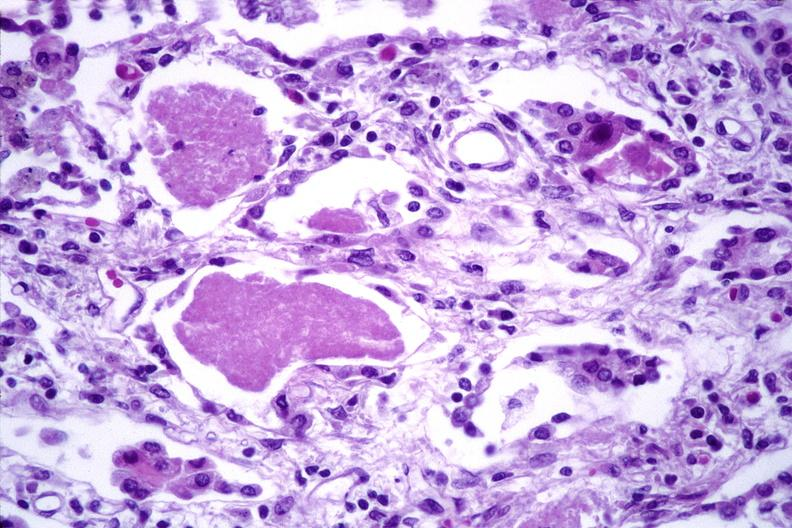does cord show lung, cyomegalovirus pneumonia and pneumocystis pneumonia?
Answer the question using a single word or phrase. No 